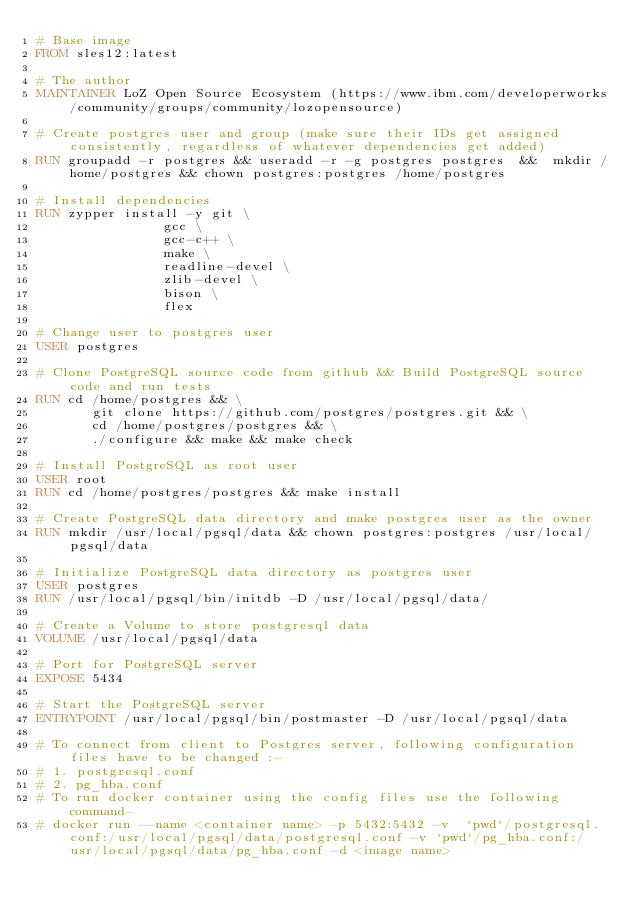Convert code to text. <code><loc_0><loc_0><loc_500><loc_500><_Dockerfile_># Base image
FROM sles12:latest

# The author
MAINTAINER LoZ Open Source Ecosystem (https://www.ibm.com/developerworks/community/groups/community/lozopensource)

# Create postgres user and group (make sure their IDs get assigned consistently, regardless of whatever dependencies get added)
RUN groupadd -r postgres && useradd -r -g postgres postgres  &&  mkdir /home/postgres && chown postgres:postgres /home/postgres

# Install dependencies
RUN zypper install -y git \
                gcc \
                gcc-c++ \
                make \
                readline-devel \
                zlib-devel \
                bison \
                flex

# Change user to postgres user
USER postgres

# Clone PostgreSQL source code from github && Build PostgreSQL source code and run tests
RUN cd /home/postgres && \
       git clone https://github.com/postgres/postgres.git && \
       cd /home/postgres/postgres && \
       ./configure && make && make check

# Install PostgreSQL as root user
USER root
RUN cd /home/postgres/postgres && make install

# Create PostgreSQL data directory and make postgres user as the owner
RUN mkdir /usr/local/pgsql/data && chown postgres:postgres /usr/local/pgsql/data

# Initialize PostgreSQL data directory as postgres user
USER postgres
RUN /usr/local/pgsql/bin/initdb -D /usr/local/pgsql/data/

# Create a Volume to store postgresql data
VOLUME /usr/local/pgsql/data

# Port for PostgreSQL server
EXPOSE 5434

# Start the PostgreSQL server
ENTRYPOINT /usr/local/pgsql/bin/postmaster -D /usr/local/pgsql/data

# To connect from client to Postgres server, following configuration files have to be changed :-
# 1. postgresql.conf
# 2. pg_hba.conf
# To run docker container using the config files use the following command-
# docker run --name <container name> -p 5432:5432 -v  `pwd`/postgresql.conf:/usr/local/pgsql/data/postgresql.conf -v `pwd`/pg_hba.conf:/usr/local/pgsql/data/pg_hba.conf -d <image name>


</code> 